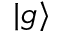Convert formula to latex. <formula><loc_0><loc_0><loc_500><loc_500>| g \rangle</formula> 